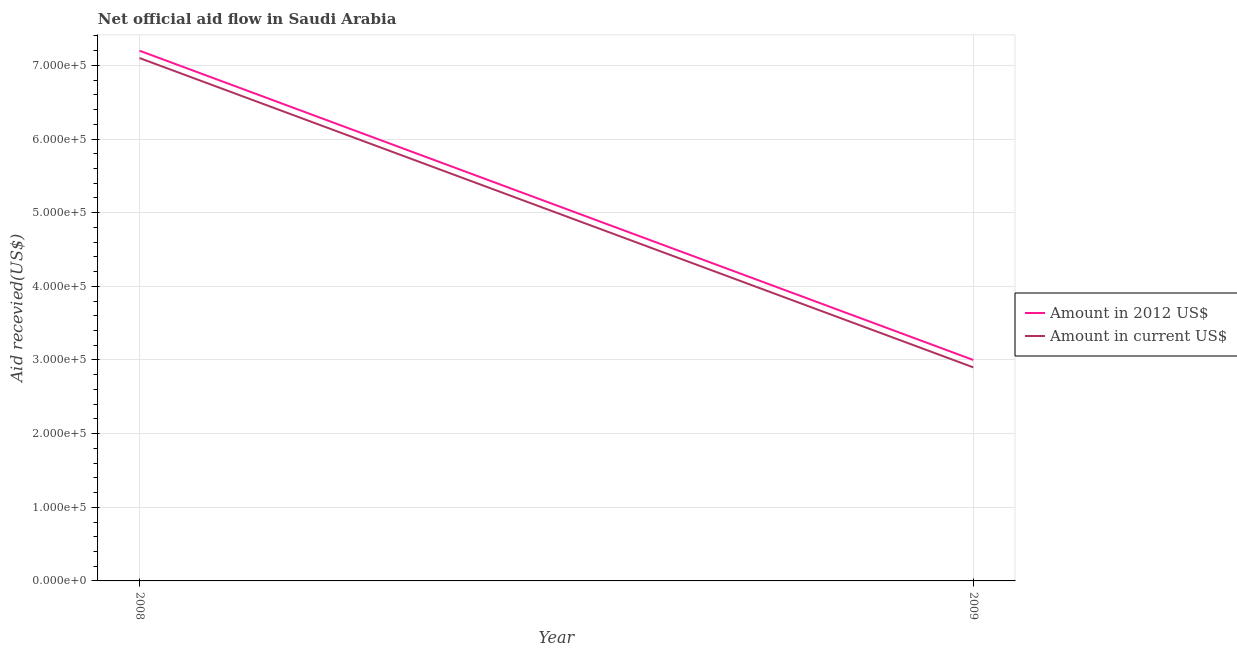How many different coloured lines are there?
Provide a short and direct response. 2. What is the amount of aid received(expressed in 2012 us$) in 2009?
Your answer should be compact. 3.00e+05. Across all years, what is the maximum amount of aid received(expressed in us$)?
Keep it short and to the point. 7.10e+05. Across all years, what is the minimum amount of aid received(expressed in us$)?
Your response must be concise. 2.90e+05. In which year was the amount of aid received(expressed in us$) minimum?
Provide a short and direct response. 2009. What is the total amount of aid received(expressed in 2012 us$) in the graph?
Offer a very short reply. 1.02e+06. What is the difference between the amount of aid received(expressed in us$) in 2008 and that in 2009?
Make the answer very short. 4.20e+05. What is the difference between the amount of aid received(expressed in us$) in 2008 and the amount of aid received(expressed in 2012 us$) in 2009?
Ensure brevity in your answer.  4.10e+05. What is the average amount of aid received(expressed in 2012 us$) per year?
Offer a terse response. 5.10e+05. In the year 2009, what is the difference between the amount of aid received(expressed in 2012 us$) and amount of aid received(expressed in us$)?
Give a very brief answer. 10000. In how many years, is the amount of aid received(expressed in 2012 us$) greater than 700000 US$?
Your response must be concise. 1. In how many years, is the amount of aid received(expressed in us$) greater than the average amount of aid received(expressed in us$) taken over all years?
Offer a terse response. 1. Is the amount of aid received(expressed in us$) strictly less than the amount of aid received(expressed in 2012 us$) over the years?
Offer a very short reply. Yes. How many years are there in the graph?
Offer a terse response. 2. What is the difference between two consecutive major ticks on the Y-axis?
Offer a terse response. 1.00e+05. How many legend labels are there?
Your response must be concise. 2. What is the title of the graph?
Keep it short and to the point. Net official aid flow in Saudi Arabia. What is the label or title of the X-axis?
Your response must be concise. Year. What is the label or title of the Y-axis?
Give a very brief answer. Aid recevied(US$). What is the Aid recevied(US$) of Amount in 2012 US$ in 2008?
Your answer should be very brief. 7.20e+05. What is the Aid recevied(US$) of Amount in current US$ in 2008?
Offer a terse response. 7.10e+05. What is the Aid recevied(US$) in Amount in 2012 US$ in 2009?
Offer a terse response. 3.00e+05. Across all years, what is the maximum Aid recevied(US$) in Amount in 2012 US$?
Give a very brief answer. 7.20e+05. Across all years, what is the maximum Aid recevied(US$) in Amount in current US$?
Provide a succinct answer. 7.10e+05. Across all years, what is the minimum Aid recevied(US$) of Amount in 2012 US$?
Provide a short and direct response. 3.00e+05. What is the total Aid recevied(US$) in Amount in 2012 US$ in the graph?
Your answer should be very brief. 1.02e+06. What is the total Aid recevied(US$) in Amount in current US$ in the graph?
Provide a succinct answer. 1.00e+06. What is the difference between the Aid recevied(US$) of Amount in current US$ in 2008 and that in 2009?
Provide a short and direct response. 4.20e+05. What is the average Aid recevied(US$) of Amount in 2012 US$ per year?
Your answer should be very brief. 5.10e+05. What is the average Aid recevied(US$) of Amount in current US$ per year?
Keep it short and to the point. 5.00e+05. What is the ratio of the Aid recevied(US$) in Amount in 2012 US$ in 2008 to that in 2009?
Provide a succinct answer. 2.4. What is the ratio of the Aid recevied(US$) of Amount in current US$ in 2008 to that in 2009?
Provide a succinct answer. 2.45. What is the difference between the highest and the second highest Aid recevied(US$) in Amount in 2012 US$?
Offer a terse response. 4.20e+05. 